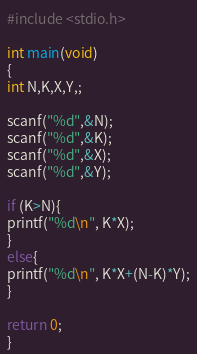Convert code to text. <code><loc_0><loc_0><loc_500><loc_500><_C_>#include <stdio.h>

int main(void)
{
int N,K,X,Y,;

scanf("%d",&N);
scanf("%d",&K);
scanf("%d",&X);
scanf("%d",&Y);

if (K>N){
printf("%d\n", K*X);
}
else{
printf("%d\n", K*X+(N-K)*Y);
}

return 0;
}</code> 